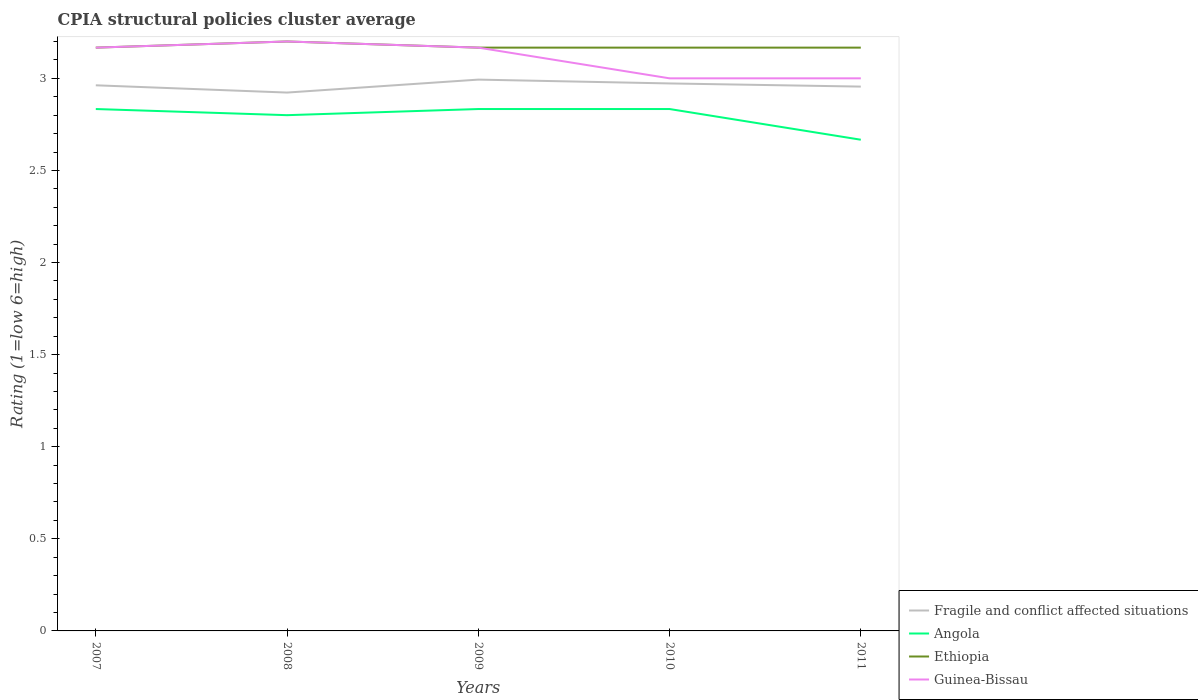Is the number of lines equal to the number of legend labels?
Keep it short and to the point. Yes. Across all years, what is the maximum CPIA rating in Angola?
Provide a short and direct response. 2.67. What is the total CPIA rating in Ethiopia in the graph?
Give a very brief answer. 0. What is the difference between the highest and the second highest CPIA rating in Guinea-Bissau?
Your response must be concise. 0.2. Is the CPIA rating in Fragile and conflict affected situations strictly greater than the CPIA rating in Ethiopia over the years?
Your answer should be very brief. Yes. How many years are there in the graph?
Your answer should be very brief. 5. Does the graph contain grids?
Ensure brevity in your answer.  No. What is the title of the graph?
Provide a succinct answer. CPIA structural policies cluster average. Does "Virgin Islands" appear as one of the legend labels in the graph?
Ensure brevity in your answer.  No. What is the label or title of the X-axis?
Your response must be concise. Years. What is the label or title of the Y-axis?
Provide a succinct answer. Rating (1=low 6=high). What is the Rating (1=low 6=high) in Fragile and conflict affected situations in 2007?
Your answer should be very brief. 2.96. What is the Rating (1=low 6=high) of Angola in 2007?
Give a very brief answer. 2.83. What is the Rating (1=low 6=high) of Ethiopia in 2007?
Provide a succinct answer. 3.17. What is the Rating (1=low 6=high) of Guinea-Bissau in 2007?
Your answer should be very brief. 3.17. What is the Rating (1=low 6=high) in Fragile and conflict affected situations in 2008?
Your answer should be very brief. 2.92. What is the Rating (1=low 6=high) of Angola in 2008?
Offer a very short reply. 2.8. What is the Rating (1=low 6=high) in Ethiopia in 2008?
Ensure brevity in your answer.  3.2. What is the Rating (1=low 6=high) of Fragile and conflict affected situations in 2009?
Your response must be concise. 2.99. What is the Rating (1=low 6=high) of Angola in 2009?
Keep it short and to the point. 2.83. What is the Rating (1=low 6=high) in Ethiopia in 2009?
Give a very brief answer. 3.17. What is the Rating (1=low 6=high) in Guinea-Bissau in 2009?
Your answer should be compact. 3.17. What is the Rating (1=low 6=high) in Fragile and conflict affected situations in 2010?
Offer a terse response. 2.97. What is the Rating (1=low 6=high) of Angola in 2010?
Your answer should be very brief. 2.83. What is the Rating (1=low 6=high) of Ethiopia in 2010?
Offer a terse response. 3.17. What is the Rating (1=low 6=high) of Fragile and conflict affected situations in 2011?
Keep it short and to the point. 2.96. What is the Rating (1=low 6=high) in Angola in 2011?
Give a very brief answer. 2.67. What is the Rating (1=low 6=high) of Ethiopia in 2011?
Offer a terse response. 3.17. Across all years, what is the maximum Rating (1=low 6=high) of Fragile and conflict affected situations?
Your answer should be very brief. 2.99. Across all years, what is the maximum Rating (1=low 6=high) in Angola?
Offer a terse response. 2.83. Across all years, what is the minimum Rating (1=low 6=high) in Fragile and conflict affected situations?
Your answer should be very brief. 2.92. Across all years, what is the minimum Rating (1=low 6=high) of Angola?
Provide a short and direct response. 2.67. Across all years, what is the minimum Rating (1=low 6=high) of Ethiopia?
Your answer should be very brief. 3.17. Across all years, what is the minimum Rating (1=low 6=high) in Guinea-Bissau?
Offer a very short reply. 3. What is the total Rating (1=low 6=high) of Fragile and conflict affected situations in the graph?
Your response must be concise. 14.81. What is the total Rating (1=low 6=high) in Angola in the graph?
Your answer should be compact. 13.97. What is the total Rating (1=low 6=high) in Ethiopia in the graph?
Give a very brief answer. 15.87. What is the total Rating (1=low 6=high) of Guinea-Bissau in the graph?
Your answer should be very brief. 15.53. What is the difference between the Rating (1=low 6=high) of Fragile and conflict affected situations in 2007 and that in 2008?
Your answer should be compact. 0.04. What is the difference between the Rating (1=low 6=high) of Ethiopia in 2007 and that in 2008?
Provide a succinct answer. -0.03. What is the difference between the Rating (1=low 6=high) of Guinea-Bissau in 2007 and that in 2008?
Provide a short and direct response. -0.03. What is the difference between the Rating (1=low 6=high) of Fragile and conflict affected situations in 2007 and that in 2009?
Your answer should be very brief. -0.03. What is the difference between the Rating (1=low 6=high) of Angola in 2007 and that in 2009?
Provide a succinct answer. 0. What is the difference between the Rating (1=low 6=high) of Ethiopia in 2007 and that in 2009?
Your answer should be very brief. 0. What is the difference between the Rating (1=low 6=high) in Guinea-Bissau in 2007 and that in 2009?
Your response must be concise. 0. What is the difference between the Rating (1=low 6=high) in Fragile and conflict affected situations in 2007 and that in 2010?
Ensure brevity in your answer.  -0.01. What is the difference between the Rating (1=low 6=high) in Fragile and conflict affected situations in 2007 and that in 2011?
Your response must be concise. 0.01. What is the difference between the Rating (1=low 6=high) of Angola in 2007 and that in 2011?
Ensure brevity in your answer.  0.17. What is the difference between the Rating (1=low 6=high) of Ethiopia in 2007 and that in 2011?
Provide a succinct answer. 0. What is the difference between the Rating (1=low 6=high) of Fragile and conflict affected situations in 2008 and that in 2009?
Your answer should be very brief. -0.07. What is the difference between the Rating (1=low 6=high) in Angola in 2008 and that in 2009?
Provide a short and direct response. -0.03. What is the difference between the Rating (1=low 6=high) of Ethiopia in 2008 and that in 2009?
Your response must be concise. 0.03. What is the difference between the Rating (1=low 6=high) in Fragile and conflict affected situations in 2008 and that in 2010?
Your response must be concise. -0.05. What is the difference between the Rating (1=low 6=high) of Angola in 2008 and that in 2010?
Provide a short and direct response. -0.03. What is the difference between the Rating (1=low 6=high) of Ethiopia in 2008 and that in 2010?
Keep it short and to the point. 0.03. What is the difference between the Rating (1=low 6=high) in Guinea-Bissau in 2008 and that in 2010?
Your answer should be compact. 0.2. What is the difference between the Rating (1=low 6=high) of Fragile and conflict affected situations in 2008 and that in 2011?
Your response must be concise. -0.03. What is the difference between the Rating (1=low 6=high) of Angola in 2008 and that in 2011?
Your response must be concise. 0.13. What is the difference between the Rating (1=low 6=high) in Ethiopia in 2008 and that in 2011?
Provide a short and direct response. 0.03. What is the difference between the Rating (1=low 6=high) of Fragile and conflict affected situations in 2009 and that in 2010?
Provide a short and direct response. 0.02. What is the difference between the Rating (1=low 6=high) in Angola in 2009 and that in 2010?
Offer a very short reply. 0. What is the difference between the Rating (1=low 6=high) of Ethiopia in 2009 and that in 2010?
Offer a very short reply. 0. What is the difference between the Rating (1=low 6=high) of Fragile and conflict affected situations in 2009 and that in 2011?
Offer a very short reply. 0.04. What is the difference between the Rating (1=low 6=high) in Angola in 2009 and that in 2011?
Your response must be concise. 0.17. What is the difference between the Rating (1=low 6=high) of Fragile and conflict affected situations in 2010 and that in 2011?
Offer a very short reply. 0.02. What is the difference between the Rating (1=low 6=high) in Angola in 2010 and that in 2011?
Offer a terse response. 0.17. What is the difference between the Rating (1=low 6=high) in Ethiopia in 2010 and that in 2011?
Provide a succinct answer. 0. What is the difference between the Rating (1=low 6=high) in Guinea-Bissau in 2010 and that in 2011?
Offer a terse response. 0. What is the difference between the Rating (1=low 6=high) of Fragile and conflict affected situations in 2007 and the Rating (1=low 6=high) of Angola in 2008?
Ensure brevity in your answer.  0.16. What is the difference between the Rating (1=low 6=high) of Fragile and conflict affected situations in 2007 and the Rating (1=low 6=high) of Ethiopia in 2008?
Keep it short and to the point. -0.24. What is the difference between the Rating (1=low 6=high) of Fragile and conflict affected situations in 2007 and the Rating (1=low 6=high) of Guinea-Bissau in 2008?
Make the answer very short. -0.24. What is the difference between the Rating (1=low 6=high) in Angola in 2007 and the Rating (1=low 6=high) in Ethiopia in 2008?
Provide a short and direct response. -0.37. What is the difference between the Rating (1=low 6=high) in Angola in 2007 and the Rating (1=low 6=high) in Guinea-Bissau in 2008?
Provide a succinct answer. -0.37. What is the difference between the Rating (1=low 6=high) of Ethiopia in 2007 and the Rating (1=low 6=high) of Guinea-Bissau in 2008?
Keep it short and to the point. -0.03. What is the difference between the Rating (1=low 6=high) in Fragile and conflict affected situations in 2007 and the Rating (1=low 6=high) in Angola in 2009?
Give a very brief answer. 0.13. What is the difference between the Rating (1=low 6=high) in Fragile and conflict affected situations in 2007 and the Rating (1=low 6=high) in Ethiopia in 2009?
Your response must be concise. -0.2. What is the difference between the Rating (1=low 6=high) in Fragile and conflict affected situations in 2007 and the Rating (1=low 6=high) in Guinea-Bissau in 2009?
Your answer should be very brief. -0.2. What is the difference between the Rating (1=low 6=high) of Angola in 2007 and the Rating (1=low 6=high) of Ethiopia in 2009?
Provide a succinct answer. -0.33. What is the difference between the Rating (1=low 6=high) in Angola in 2007 and the Rating (1=low 6=high) in Guinea-Bissau in 2009?
Offer a terse response. -0.33. What is the difference between the Rating (1=low 6=high) in Ethiopia in 2007 and the Rating (1=low 6=high) in Guinea-Bissau in 2009?
Your answer should be very brief. 0. What is the difference between the Rating (1=low 6=high) in Fragile and conflict affected situations in 2007 and the Rating (1=low 6=high) in Angola in 2010?
Make the answer very short. 0.13. What is the difference between the Rating (1=low 6=high) of Fragile and conflict affected situations in 2007 and the Rating (1=low 6=high) of Ethiopia in 2010?
Make the answer very short. -0.2. What is the difference between the Rating (1=low 6=high) of Fragile and conflict affected situations in 2007 and the Rating (1=low 6=high) of Guinea-Bissau in 2010?
Ensure brevity in your answer.  -0.04. What is the difference between the Rating (1=low 6=high) of Ethiopia in 2007 and the Rating (1=low 6=high) of Guinea-Bissau in 2010?
Your answer should be very brief. 0.17. What is the difference between the Rating (1=low 6=high) in Fragile and conflict affected situations in 2007 and the Rating (1=low 6=high) in Angola in 2011?
Make the answer very short. 0.3. What is the difference between the Rating (1=low 6=high) in Fragile and conflict affected situations in 2007 and the Rating (1=low 6=high) in Ethiopia in 2011?
Make the answer very short. -0.2. What is the difference between the Rating (1=low 6=high) of Fragile and conflict affected situations in 2007 and the Rating (1=low 6=high) of Guinea-Bissau in 2011?
Offer a terse response. -0.04. What is the difference between the Rating (1=low 6=high) of Angola in 2007 and the Rating (1=low 6=high) of Guinea-Bissau in 2011?
Provide a short and direct response. -0.17. What is the difference between the Rating (1=low 6=high) in Ethiopia in 2007 and the Rating (1=low 6=high) in Guinea-Bissau in 2011?
Keep it short and to the point. 0.17. What is the difference between the Rating (1=low 6=high) in Fragile and conflict affected situations in 2008 and the Rating (1=low 6=high) in Angola in 2009?
Provide a succinct answer. 0.09. What is the difference between the Rating (1=low 6=high) of Fragile and conflict affected situations in 2008 and the Rating (1=low 6=high) of Ethiopia in 2009?
Ensure brevity in your answer.  -0.24. What is the difference between the Rating (1=low 6=high) in Fragile and conflict affected situations in 2008 and the Rating (1=low 6=high) in Guinea-Bissau in 2009?
Provide a succinct answer. -0.24. What is the difference between the Rating (1=low 6=high) of Angola in 2008 and the Rating (1=low 6=high) of Ethiopia in 2009?
Keep it short and to the point. -0.37. What is the difference between the Rating (1=low 6=high) of Angola in 2008 and the Rating (1=low 6=high) of Guinea-Bissau in 2009?
Give a very brief answer. -0.37. What is the difference between the Rating (1=low 6=high) of Fragile and conflict affected situations in 2008 and the Rating (1=low 6=high) of Angola in 2010?
Provide a short and direct response. 0.09. What is the difference between the Rating (1=low 6=high) of Fragile and conflict affected situations in 2008 and the Rating (1=low 6=high) of Ethiopia in 2010?
Make the answer very short. -0.24. What is the difference between the Rating (1=low 6=high) of Fragile and conflict affected situations in 2008 and the Rating (1=low 6=high) of Guinea-Bissau in 2010?
Your answer should be very brief. -0.08. What is the difference between the Rating (1=low 6=high) in Angola in 2008 and the Rating (1=low 6=high) in Ethiopia in 2010?
Your response must be concise. -0.37. What is the difference between the Rating (1=low 6=high) in Fragile and conflict affected situations in 2008 and the Rating (1=low 6=high) in Angola in 2011?
Ensure brevity in your answer.  0.26. What is the difference between the Rating (1=low 6=high) in Fragile and conflict affected situations in 2008 and the Rating (1=low 6=high) in Ethiopia in 2011?
Offer a terse response. -0.24. What is the difference between the Rating (1=low 6=high) in Fragile and conflict affected situations in 2008 and the Rating (1=low 6=high) in Guinea-Bissau in 2011?
Your answer should be compact. -0.08. What is the difference between the Rating (1=low 6=high) of Angola in 2008 and the Rating (1=low 6=high) of Ethiopia in 2011?
Make the answer very short. -0.37. What is the difference between the Rating (1=low 6=high) of Angola in 2008 and the Rating (1=low 6=high) of Guinea-Bissau in 2011?
Provide a short and direct response. -0.2. What is the difference between the Rating (1=low 6=high) in Ethiopia in 2008 and the Rating (1=low 6=high) in Guinea-Bissau in 2011?
Provide a short and direct response. 0.2. What is the difference between the Rating (1=low 6=high) in Fragile and conflict affected situations in 2009 and the Rating (1=low 6=high) in Angola in 2010?
Provide a succinct answer. 0.16. What is the difference between the Rating (1=low 6=high) of Fragile and conflict affected situations in 2009 and the Rating (1=low 6=high) of Ethiopia in 2010?
Offer a terse response. -0.17. What is the difference between the Rating (1=low 6=high) in Fragile and conflict affected situations in 2009 and the Rating (1=low 6=high) in Guinea-Bissau in 2010?
Ensure brevity in your answer.  -0.01. What is the difference between the Rating (1=low 6=high) of Angola in 2009 and the Rating (1=low 6=high) of Guinea-Bissau in 2010?
Give a very brief answer. -0.17. What is the difference between the Rating (1=low 6=high) in Ethiopia in 2009 and the Rating (1=low 6=high) in Guinea-Bissau in 2010?
Your answer should be very brief. 0.17. What is the difference between the Rating (1=low 6=high) in Fragile and conflict affected situations in 2009 and the Rating (1=low 6=high) in Angola in 2011?
Your answer should be compact. 0.33. What is the difference between the Rating (1=low 6=high) in Fragile and conflict affected situations in 2009 and the Rating (1=low 6=high) in Ethiopia in 2011?
Provide a succinct answer. -0.17. What is the difference between the Rating (1=low 6=high) in Fragile and conflict affected situations in 2009 and the Rating (1=low 6=high) in Guinea-Bissau in 2011?
Offer a terse response. -0.01. What is the difference between the Rating (1=low 6=high) in Angola in 2009 and the Rating (1=low 6=high) in Guinea-Bissau in 2011?
Keep it short and to the point. -0.17. What is the difference between the Rating (1=low 6=high) in Ethiopia in 2009 and the Rating (1=low 6=high) in Guinea-Bissau in 2011?
Make the answer very short. 0.17. What is the difference between the Rating (1=low 6=high) in Fragile and conflict affected situations in 2010 and the Rating (1=low 6=high) in Angola in 2011?
Make the answer very short. 0.31. What is the difference between the Rating (1=low 6=high) of Fragile and conflict affected situations in 2010 and the Rating (1=low 6=high) of Ethiopia in 2011?
Provide a short and direct response. -0.19. What is the difference between the Rating (1=low 6=high) in Fragile and conflict affected situations in 2010 and the Rating (1=low 6=high) in Guinea-Bissau in 2011?
Give a very brief answer. -0.03. What is the difference between the Rating (1=low 6=high) in Angola in 2010 and the Rating (1=low 6=high) in Guinea-Bissau in 2011?
Offer a terse response. -0.17. What is the average Rating (1=low 6=high) in Fragile and conflict affected situations per year?
Offer a very short reply. 2.96. What is the average Rating (1=low 6=high) in Angola per year?
Provide a short and direct response. 2.79. What is the average Rating (1=low 6=high) in Ethiopia per year?
Give a very brief answer. 3.17. What is the average Rating (1=low 6=high) in Guinea-Bissau per year?
Offer a very short reply. 3.11. In the year 2007, what is the difference between the Rating (1=low 6=high) in Fragile and conflict affected situations and Rating (1=low 6=high) in Angola?
Your answer should be very brief. 0.13. In the year 2007, what is the difference between the Rating (1=low 6=high) of Fragile and conflict affected situations and Rating (1=low 6=high) of Ethiopia?
Your answer should be very brief. -0.2. In the year 2007, what is the difference between the Rating (1=low 6=high) in Fragile and conflict affected situations and Rating (1=low 6=high) in Guinea-Bissau?
Your response must be concise. -0.2. In the year 2007, what is the difference between the Rating (1=low 6=high) in Angola and Rating (1=low 6=high) in Guinea-Bissau?
Provide a succinct answer. -0.33. In the year 2007, what is the difference between the Rating (1=low 6=high) in Ethiopia and Rating (1=low 6=high) in Guinea-Bissau?
Ensure brevity in your answer.  0. In the year 2008, what is the difference between the Rating (1=low 6=high) of Fragile and conflict affected situations and Rating (1=low 6=high) of Angola?
Your answer should be very brief. 0.12. In the year 2008, what is the difference between the Rating (1=low 6=high) in Fragile and conflict affected situations and Rating (1=low 6=high) in Ethiopia?
Make the answer very short. -0.28. In the year 2008, what is the difference between the Rating (1=low 6=high) in Fragile and conflict affected situations and Rating (1=low 6=high) in Guinea-Bissau?
Your response must be concise. -0.28. In the year 2008, what is the difference between the Rating (1=low 6=high) of Ethiopia and Rating (1=low 6=high) of Guinea-Bissau?
Ensure brevity in your answer.  0. In the year 2009, what is the difference between the Rating (1=low 6=high) of Fragile and conflict affected situations and Rating (1=low 6=high) of Angola?
Your answer should be very brief. 0.16. In the year 2009, what is the difference between the Rating (1=low 6=high) in Fragile and conflict affected situations and Rating (1=low 6=high) in Ethiopia?
Your answer should be very brief. -0.17. In the year 2009, what is the difference between the Rating (1=low 6=high) in Fragile and conflict affected situations and Rating (1=low 6=high) in Guinea-Bissau?
Give a very brief answer. -0.17. In the year 2009, what is the difference between the Rating (1=low 6=high) of Angola and Rating (1=low 6=high) of Guinea-Bissau?
Keep it short and to the point. -0.33. In the year 2010, what is the difference between the Rating (1=low 6=high) of Fragile and conflict affected situations and Rating (1=low 6=high) of Angola?
Provide a succinct answer. 0.14. In the year 2010, what is the difference between the Rating (1=low 6=high) in Fragile and conflict affected situations and Rating (1=low 6=high) in Ethiopia?
Give a very brief answer. -0.19. In the year 2010, what is the difference between the Rating (1=low 6=high) of Fragile and conflict affected situations and Rating (1=low 6=high) of Guinea-Bissau?
Your answer should be very brief. -0.03. In the year 2010, what is the difference between the Rating (1=low 6=high) in Angola and Rating (1=low 6=high) in Guinea-Bissau?
Your answer should be compact. -0.17. In the year 2010, what is the difference between the Rating (1=low 6=high) of Ethiopia and Rating (1=low 6=high) of Guinea-Bissau?
Offer a terse response. 0.17. In the year 2011, what is the difference between the Rating (1=low 6=high) in Fragile and conflict affected situations and Rating (1=low 6=high) in Angola?
Keep it short and to the point. 0.29. In the year 2011, what is the difference between the Rating (1=low 6=high) of Fragile and conflict affected situations and Rating (1=low 6=high) of Ethiopia?
Make the answer very short. -0.21. In the year 2011, what is the difference between the Rating (1=low 6=high) in Fragile and conflict affected situations and Rating (1=low 6=high) in Guinea-Bissau?
Provide a succinct answer. -0.04. In the year 2011, what is the difference between the Rating (1=low 6=high) of Angola and Rating (1=low 6=high) of Ethiopia?
Offer a terse response. -0.5. What is the ratio of the Rating (1=low 6=high) of Fragile and conflict affected situations in 2007 to that in 2008?
Provide a succinct answer. 1.01. What is the ratio of the Rating (1=low 6=high) in Angola in 2007 to that in 2008?
Keep it short and to the point. 1.01. What is the ratio of the Rating (1=low 6=high) of Angola in 2007 to that in 2009?
Make the answer very short. 1. What is the ratio of the Rating (1=low 6=high) in Fragile and conflict affected situations in 2007 to that in 2010?
Your answer should be compact. 1. What is the ratio of the Rating (1=low 6=high) in Angola in 2007 to that in 2010?
Offer a terse response. 1. What is the ratio of the Rating (1=low 6=high) in Ethiopia in 2007 to that in 2010?
Your answer should be very brief. 1. What is the ratio of the Rating (1=low 6=high) of Guinea-Bissau in 2007 to that in 2010?
Your answer should be compact. 1.06. What is the ratio of the Rating (1=low 6=high) of Angola in 2007 to that in 2011?
Keep it short and to the point. 1.06. What is the ratio of the Rating (1=low 6=high) of Guinea-Bissau in 2007 to that in 2011?
Make the answer very short. 1.06. What is the ratio of the Rating (1=low 6=high) of Fragile and conflict affected situations in 2008 to that in 2009?
Provide a short and direct response. 0.98. What is the ratio of the Rating (1=low 6=high) of Angola in 2008 to that in 2009?
Keep it short and to the point. 0.99. What is the ratio of the Rating (1=low 6=high) in Ethiopia in 2008 to that in 2009?
Offer a terse response. 1.01. What is the ratio of the Rating (1=low 6=high) of Guinea-Bissau in 2008 to that in 2009?
Keep it short and to the point. 1.01. What is the ratio of the Rating (1=low 6=high) of Fragile and conflict affected situations in 2008 to that in 2010?
Ensure brevity in your answer.  0.98. What is the ratio of the Rating (1=low 6=high) in Ethiopia in 2008 to that in 2010?
Ensure brevity in your answer.  1.01. What is the ratio of the Rating (1=low 6=high) in Guinea-Bissau in 2008 to that in 2010?
Your response must be concise. 1.07. What is the ratio of the Rating (1=low 6=high) in Fragile and conflict affected situations in 2008 to that in 2011?
Your answer should be very brief. 0.99. What is the ratio of the Rating (1=low 6=high) of Angola in 2008 to that in 2011?
Keep it short and to the point. 1.05. What is the ratio of the Rating (1=low 6=high) of Ethiopia in 2008 to that in 2011?
Give a very brief answer. 1.01. What is the ratio of the Rating (1=low 6=high) of Guinea-Bissau in 2008 to that in 2011?
Provide a succinct answer. 1.07. What is the ratio of the Rating (1=low 6=high) in Fragile and conflict affected situations in 2009 to that in 2010?
Your answer should be compact. 1.01. What is the ratio of the Rating (1=low 6=high) of Angola in 2009 to that in 2010?
Give a very brief answer. 1. What is the ratio of the Rating (1=low 6=high) in Guinea-Bissau in 2009 to that in 2010?
Give a very brief answer. 1.06. What is the ratio of the Rating (1=low 6=high) of Fragile and conflict affected situations in 2009 to that in 2011?
Offer a very short reply. 1.01. What is the ratio of the Rating (1=low 6=high) in Angola in 2009 to that in 2011?
Your response must be concise. 1.06. What is the ratio of the Rating (1=low 6=high) of Ethiopia in 2009 to that in 2011?
Give a very brief answer. 1. What is the ratio of the Rating (1=low 6=high) of Guinea-Bissau in 2009 to that in 2011?
Offer a very short reply. 1.06. What is the difference between the highest and the second highest Rating (1=low 6=high) of Fragile and conflict affected situations?
Your response must be concise. 0.02. What is the difference between the highest and the second highest Rating (1=low 6=high) of Guinea-Bissau?
Your answer should be compact. 0.03. What is the difference between the highest and the lowest Rating (1=low 6=high) in Fragile and conflict affected situations?
Provide a short and direct response. 0.07. What is the difference between the highest and the lowest Rating (1=low 6=high) of Ethiopia?
Make the answer very short. 0.03. What is the difference between the highest and the lowest Rating (1=low 6=high) of Guinea-Bissau?
Give a very brief answer. 0.2. 